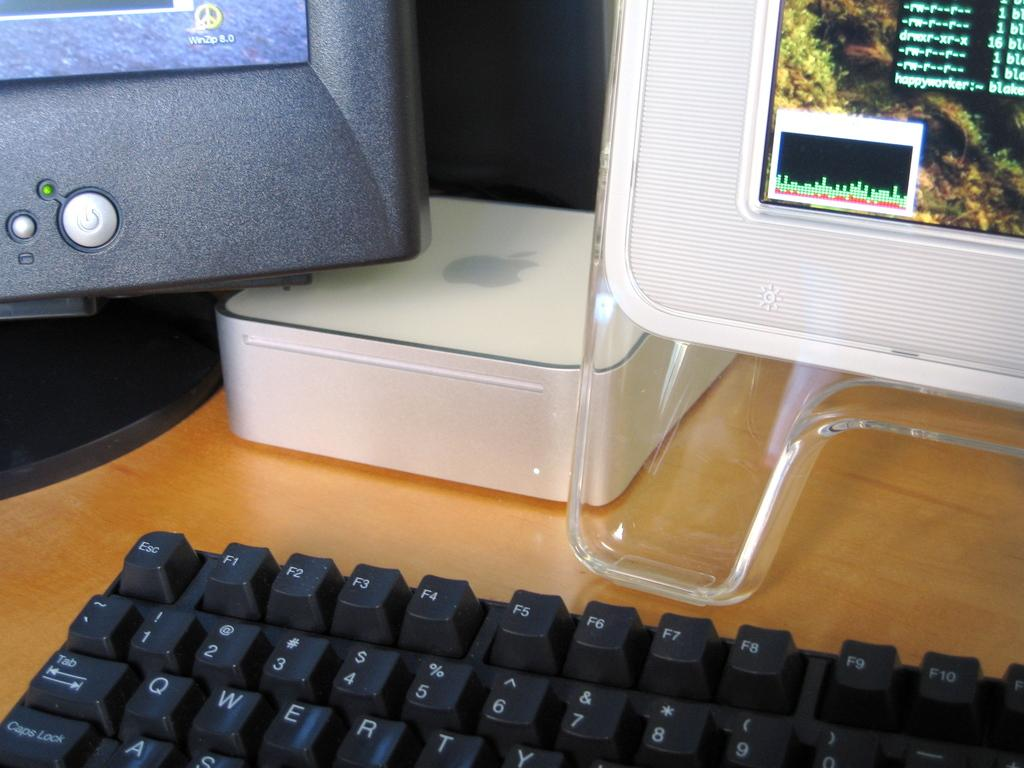What type of device is visible in the image? There is a keyboard and a monitor in the image. What is the primary purpose of the keyboard? The keyboard is used for typing and inputting commands. What is the screen attached to? The screen is attached to the monitor. What is the box in the image used for? The purpose of the box is not specified in the image. What is the surface that the objects are placed on? The objects are on a wooden surface. Can you see any fangs on the keyboard in the image? There are no fangs present on the keyboard in the image. Is there any snow visible on the wooden surface in the image? There is no snow visible on the wooden surface in the image. 